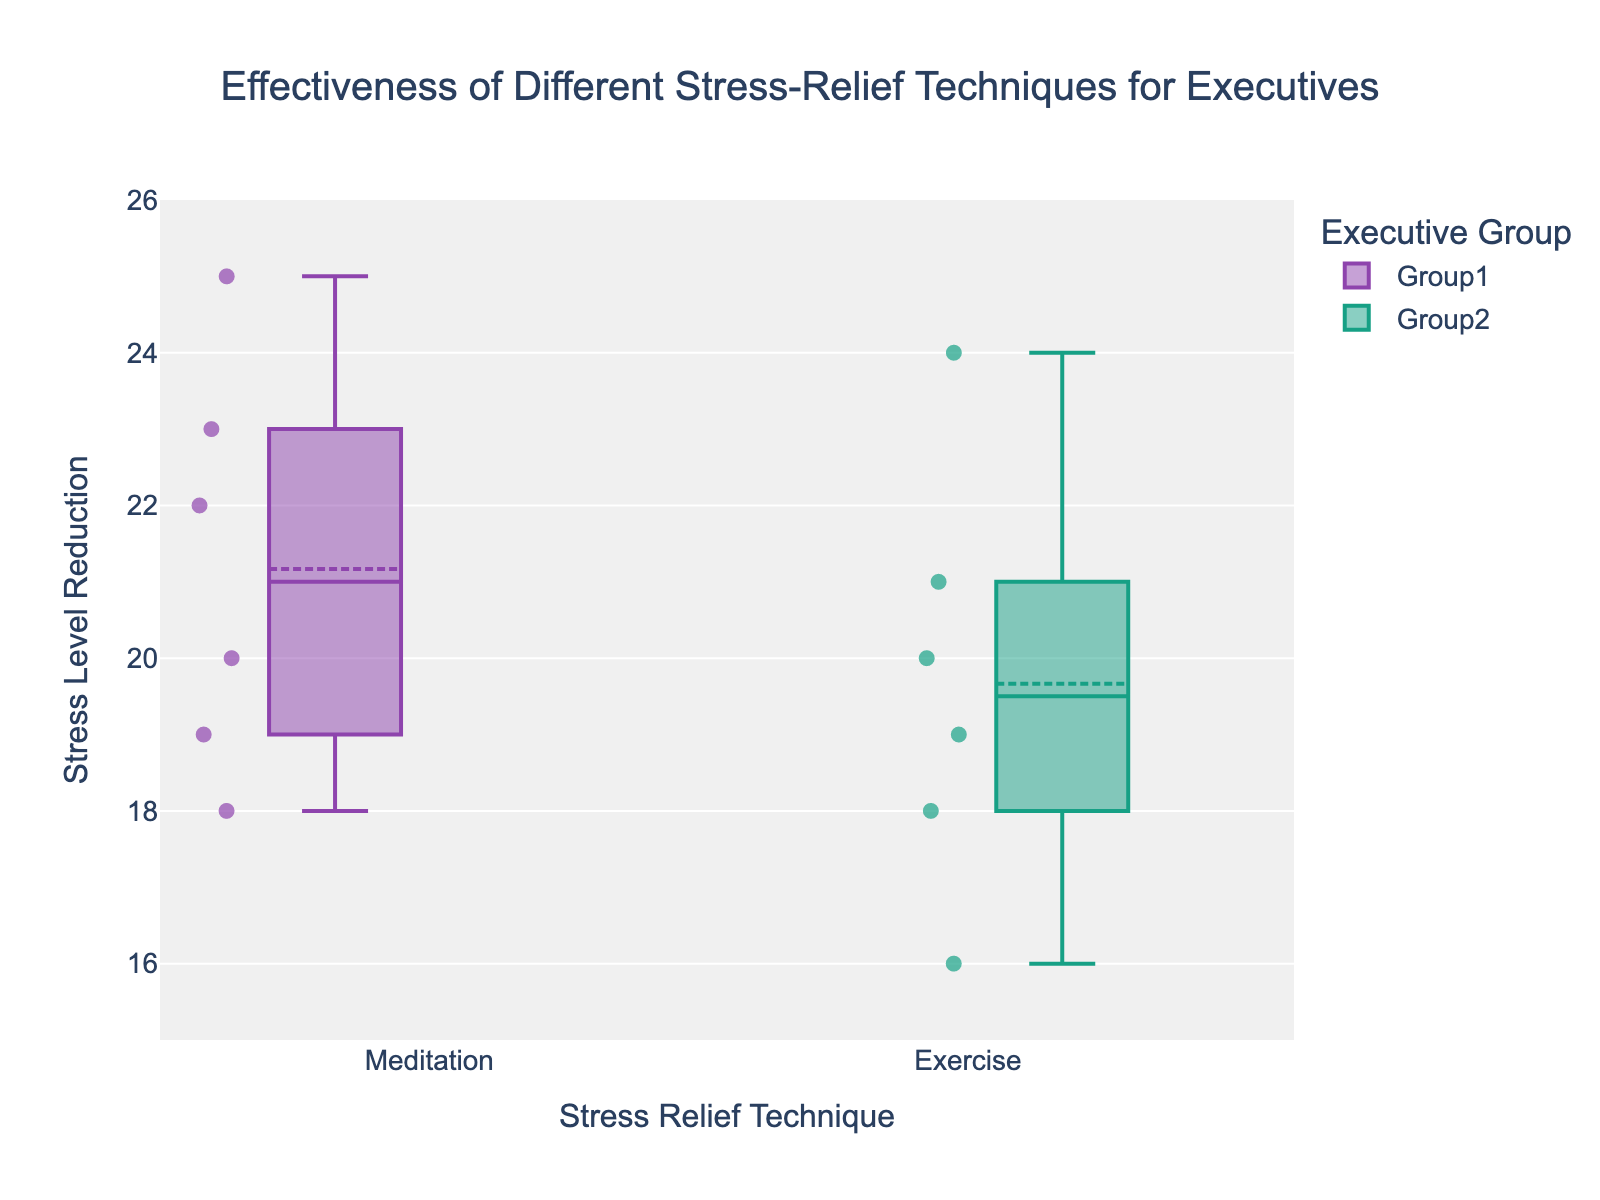How many different stress relief techniques are displayed in the plot? The x-axis represents the stress relief techniques, and two techniques are shown: "Meditation" and "Exercise".
Answer: 2 What is the title of the figure? The title is displayed at the top of the figure.
Answer: Effectiveness of Different Stress-Relief Techniques for Executives What is the range of the y-axis? The y-axis ranges from a minimum value of 15 to a maximum value of 26.
Answer: 15-26 Which stress relief technique shows a higher median stress level reduction for Group 1? The median value is indicated by the line inside each box. For Group 1, the median for "Meditation" is higher than "Exercise".
Answer: Meditation What is the average stress level reduction for Group 1 using Meditation? The data points for Group 1, Meditation are 18, 22, 19, 25, 20, 23. Sum these values and divide by the number of data points: (18 + 22 + 19 + 25 + 20 + 23) / 6 = 127 / 6 = 21.17
Answer: 21.17 What is the interquartile range (IQR) for Group 2 using Exercise? The IQR is calculated by subtracting the first quartile (Q1) from the third quartile (Q3). From the box plot, Q1 is approximately 18 and Q3 is approximately 21. Hence, IQR = Q3 - Q1 = 21 - 18 = 3
Answer: 3 What is the maximum stress level reduction observed for Group 2 using Exercise? The maximum value can be identified from the top whisker or any outliers above the box plot for Group 2 using Exercise. The maximum value is 24.
Answer: 24 Which group shows more variability in stress level reduction using Exercise? Variability can be judged by the height of the box, including whiskers, in the box plot. Group 2 shows more variability compared to Group 1 for Exercise.
Answer: Group 2 Is there any overlap in the stress level reduction values between Group 1 and Group 2 for Meditation? By looking at the box plots for Meditation in both groups, we can see that there is an overlap in the values between the first and third quartiles.
Answer: Yes Compare the highest values of stress level reduction between Meditation and Exercise for Group 2. Which technique showed a higher reduction? The highest values are indicated by the top whiskers or outliers. For Group 2, Meditation has a maximum of 23, and Exercise has a maximum of 24. Exercise has a higher reduction.
Answer: Exercise 